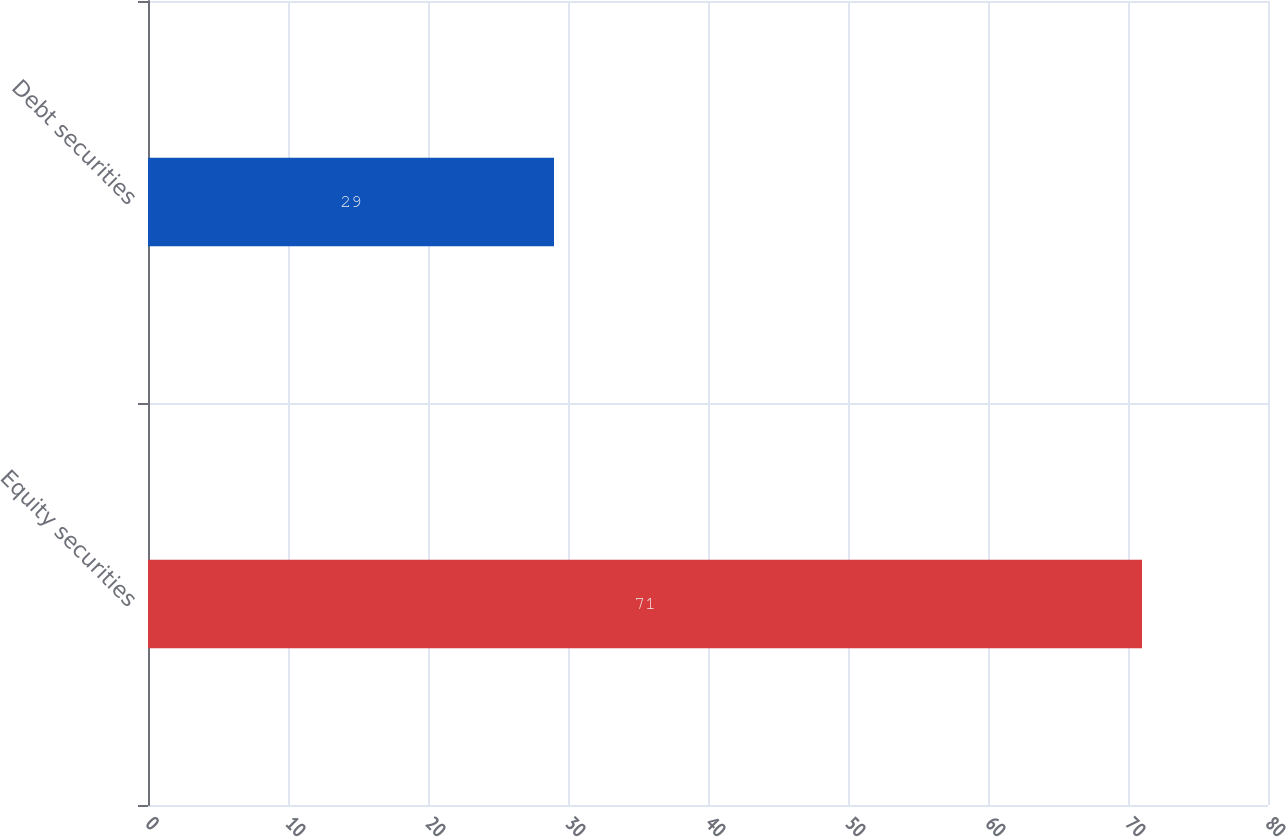Convert chart. <chart><loc_0><loc_0><loc_500><loc_500><bar_chart><fcel>Equity securities<fcel>Debt securities<nl><fcel>71<fcel>29<nl></chart> 